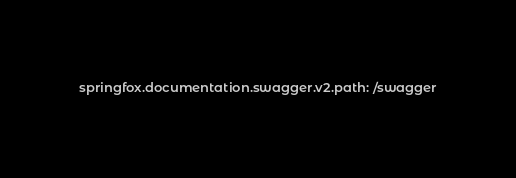Convert code to text. <code><loc_0><loc_0><loc_500><loc_500><_YAML_>springfox.documentation.swagger.v2.path: /swagger</code> 